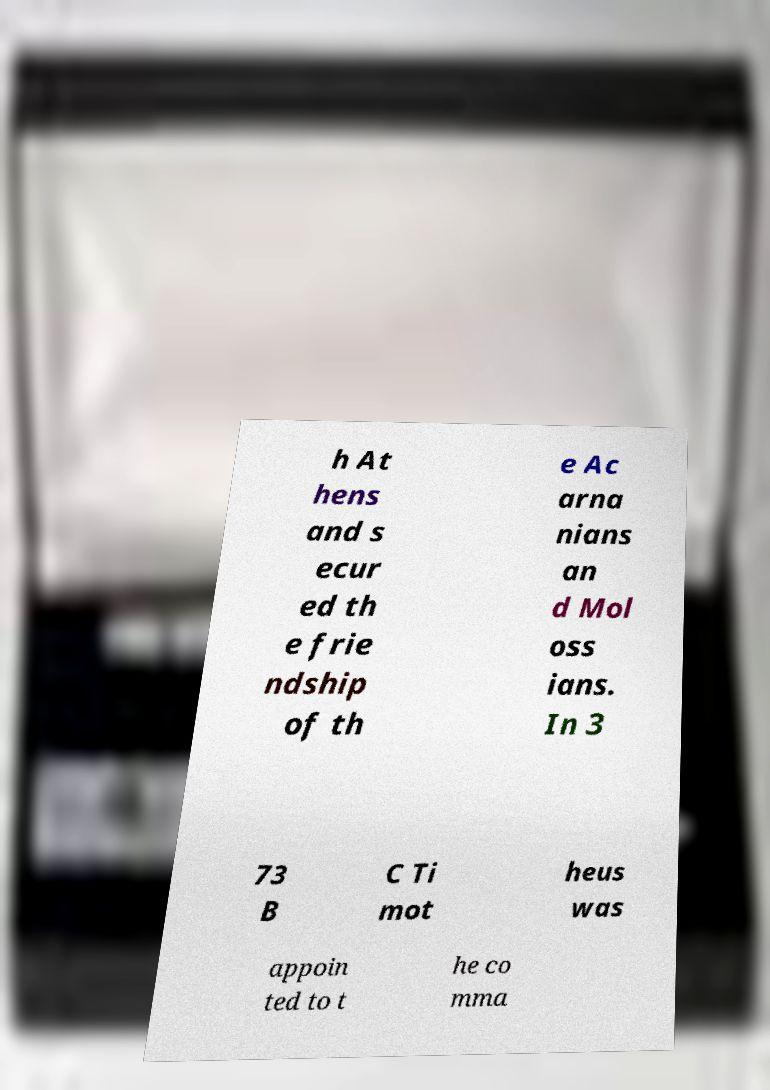Please read and relay the text visible in this image. What does it say? h At hens and s ecur ed th e frie ndship of th e Ac arna nians an d Mol oss ians. In 3 73 B C Ti mot heus was appoin ted to t he co mma 